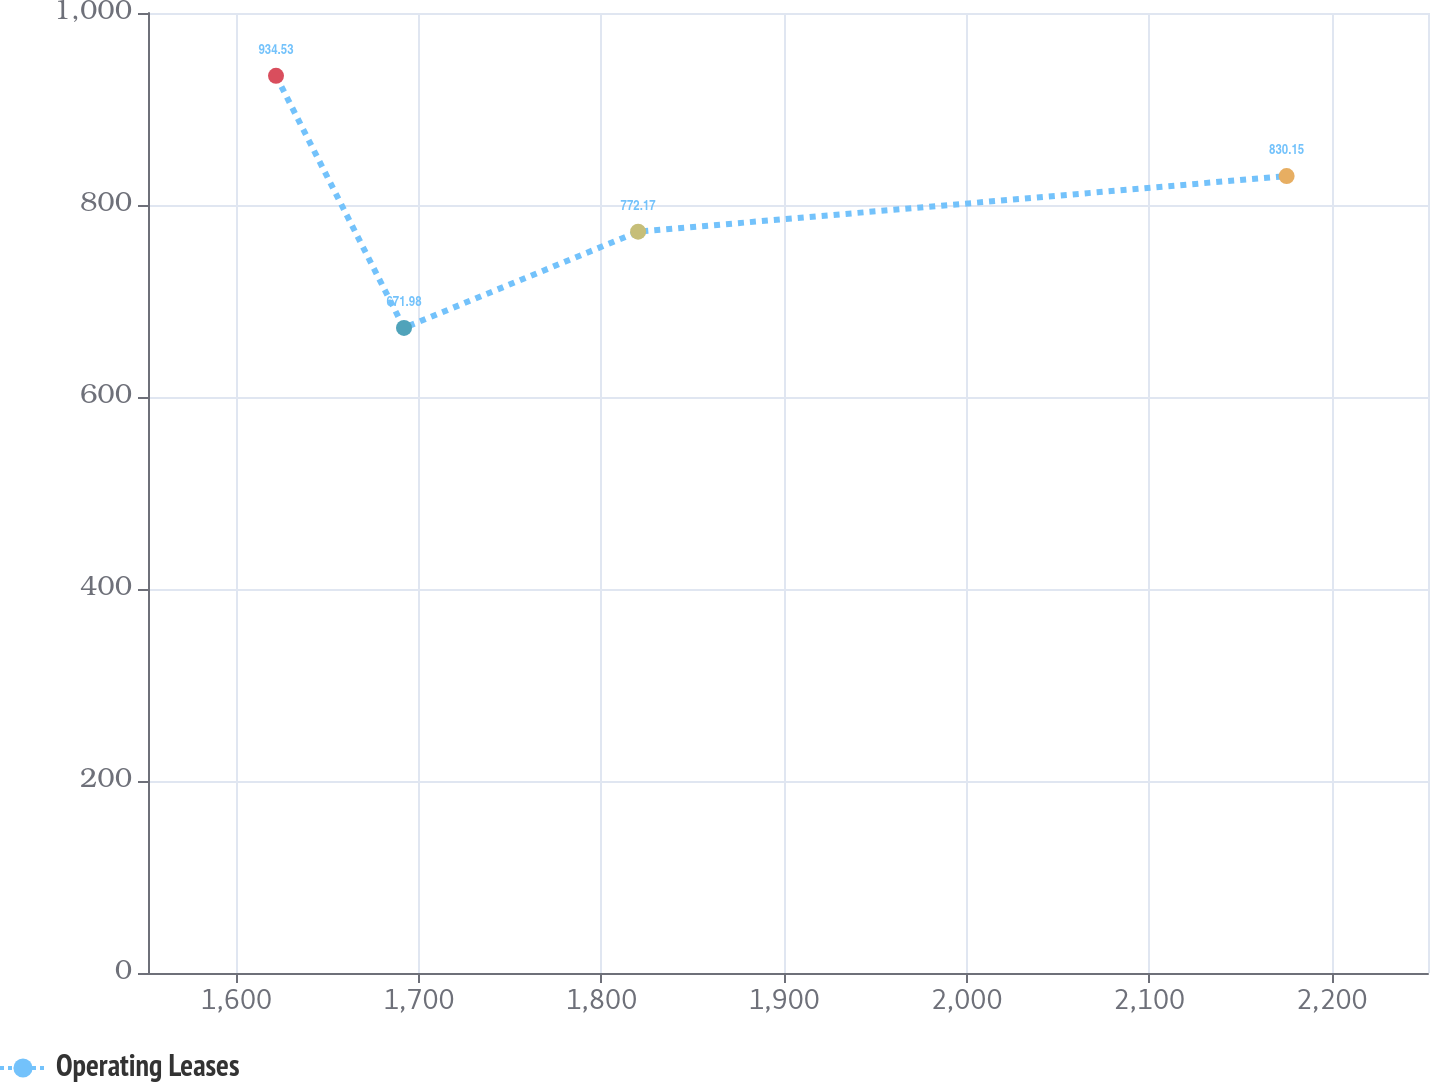Convert chart. <chart><loc_0><loc_0><loc_500><loc_500><line_chart><ecel><fcel>Operating Leases<nl><fcel>1621.8<fcel>934.53<nl><fcel>1691.9<fcel>671.98<nl><fcel>1820.1<fcel>772.17<nl><fcel>2175.25<fcel>830.15<nl><fcel>2322.77<fcel>798.42<nl></chart> 